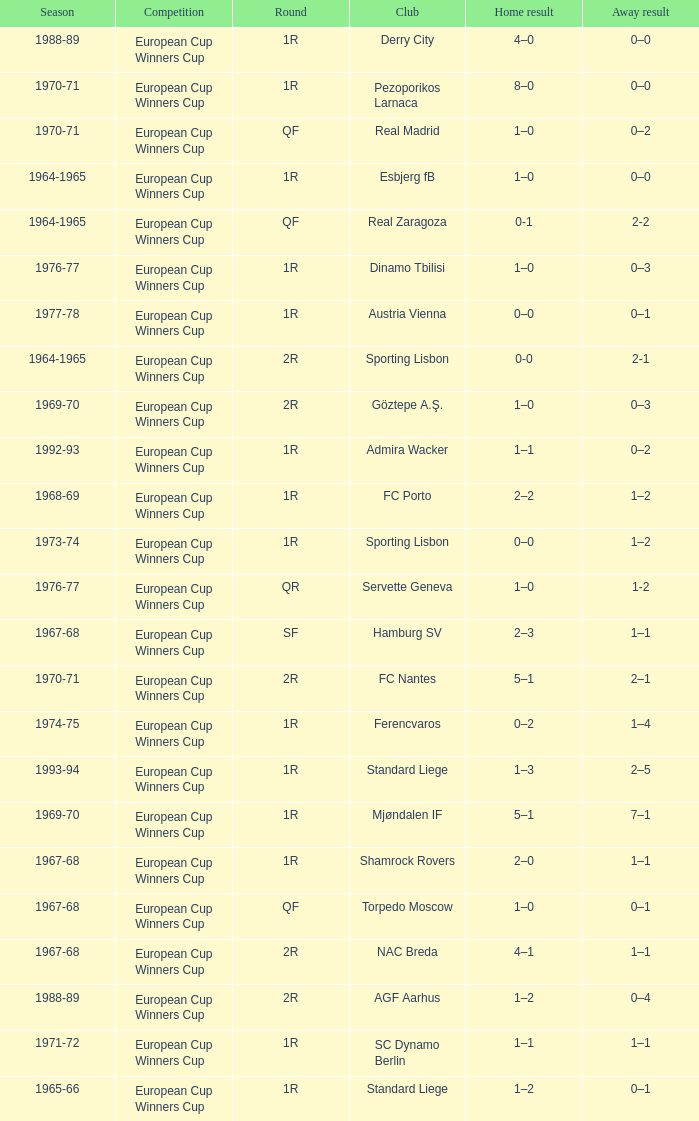Round of 1r, and an away result of 7–1 is what season? 1969-70. 